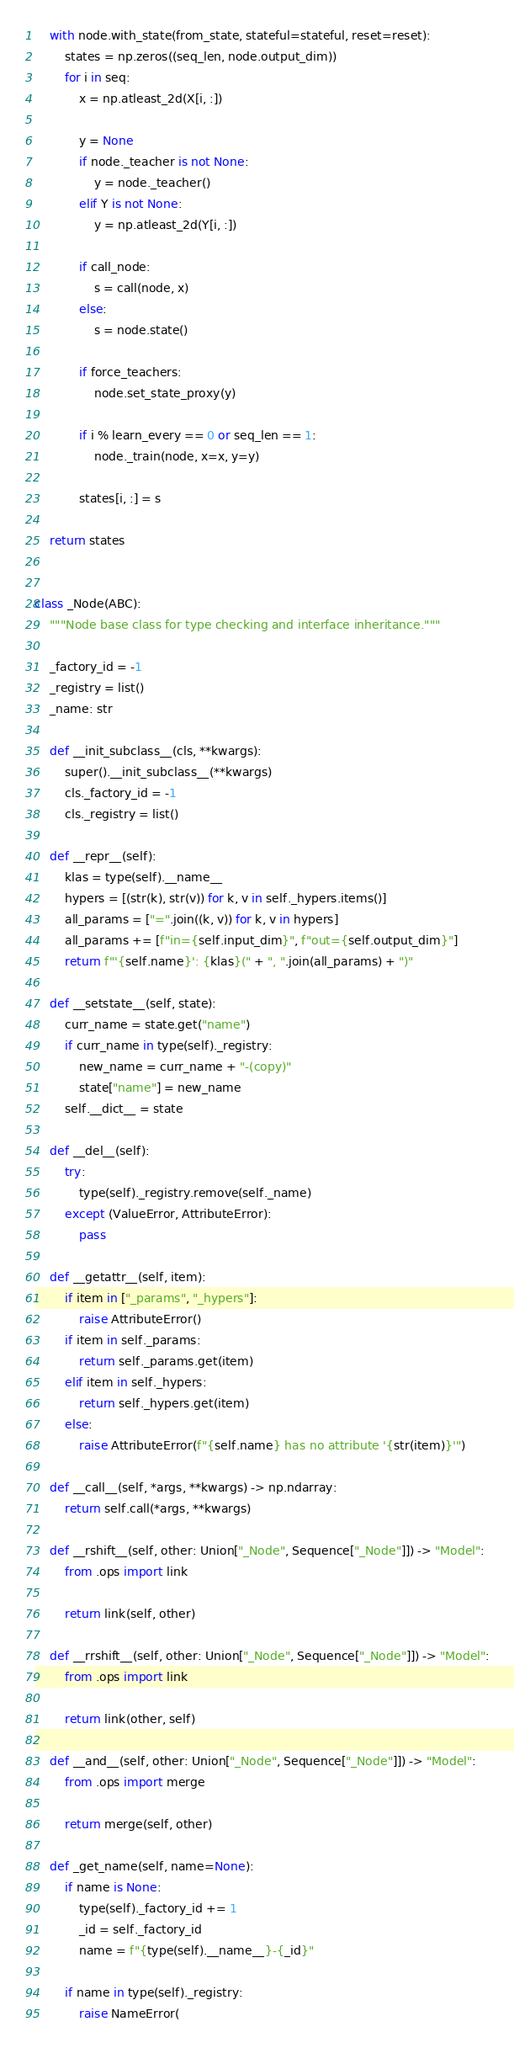Convert code to text. <code><loc_0><loc_0><loc_500><loc_500><_Python_>    with node.with_state(from_state, stateful=stateful, reset=reset):
        states = np.zeros((seq_len, node.output_dim))
        for i in seq:
            x = np.atleast_2d(X[i, :])

            y = None
            if node._teacher is not None:
                y = node._teacher()
            elif Y is not None:
                y = np.atleast_2d(Y[i, :])

            if call_node:
                s = call(node, x)
            else:
                s = node.state()

            if force_teachers:
                node.set_state_proxy(y)

            if i % learn_every == 0 or seq_len == 1:
                node._train(node, x=x, y=y)

            states[i, :] = s

    return states


class _Node(ABC):
    """Node base class for type checking and interface inheritance."""

    _factory_id = -1
    _registry = list()
    _name: str

    def __init_subclass__(cls, **kwargs):
        super().__init_subclass__(**kwargs)
        cls._factory_id = -1
        cls._registry = list()

    def __repr__(self):
        klas = type(self).__name__
        hypers = [(str(k), str(v)) for k, v in self._hypers.items()]
        all_params = ["=".join((k, v)) for k, v in hypers]
        all_params += [f"in={self.input_dim}", f"out={self.output_dim}"]
        return f"'{self.name}': {klas}(" + ", ".join(all_params) + ")"

    def __setstate__(self, state):
        curr_name = state.get("name")
        if curr_name in type(self)._registry:
            new_name = curr_name + "-(copy)"
            state["name"] = new_name
        self.__dict__ = state

    def __del__(self):
        try:
            type(self)._registry.remove(self._name)
        except (ValueError, AttributeError):
            pass

    def __getattr__(self, item):
        if item in ["_params", "_hypers"]:
            raise AttributeError()
        if item in self._params:
            return self._params.get(item)
        elif item in self._hypers:
            return self._hypers.get(item)
        else:
            raise AttributeError(f"{self.name} has no attribute '{str(item)}'")

    def __call__(self, *args, **kwargs) -> np.ndarray:
        return self.call(*args, **kwargs)

    def __rshift__(self, other: Union["_Node", Sequence["_Node"]]) -> "Model":
        from .ops import link

        return link(self, other)

    def __rrshift__(self, other: Union["_Node", Sequence["_Node"]]) -> "Model":
        from .ops import link

        return link(other, self)

    def __and__(self, other: Union["_Node", Sequence["_Node"]]) -> "Model":
        from .ops import merge

        return merge(self, other)

    def _get_name(self, name=None):
        if name is None:
            type(self)._factory_id += 1
            _id = self._factory_id
            name = f"{type(self).__name__}-{_id}"

        if name in type(self)._registry:
            raise NameError(</code> 